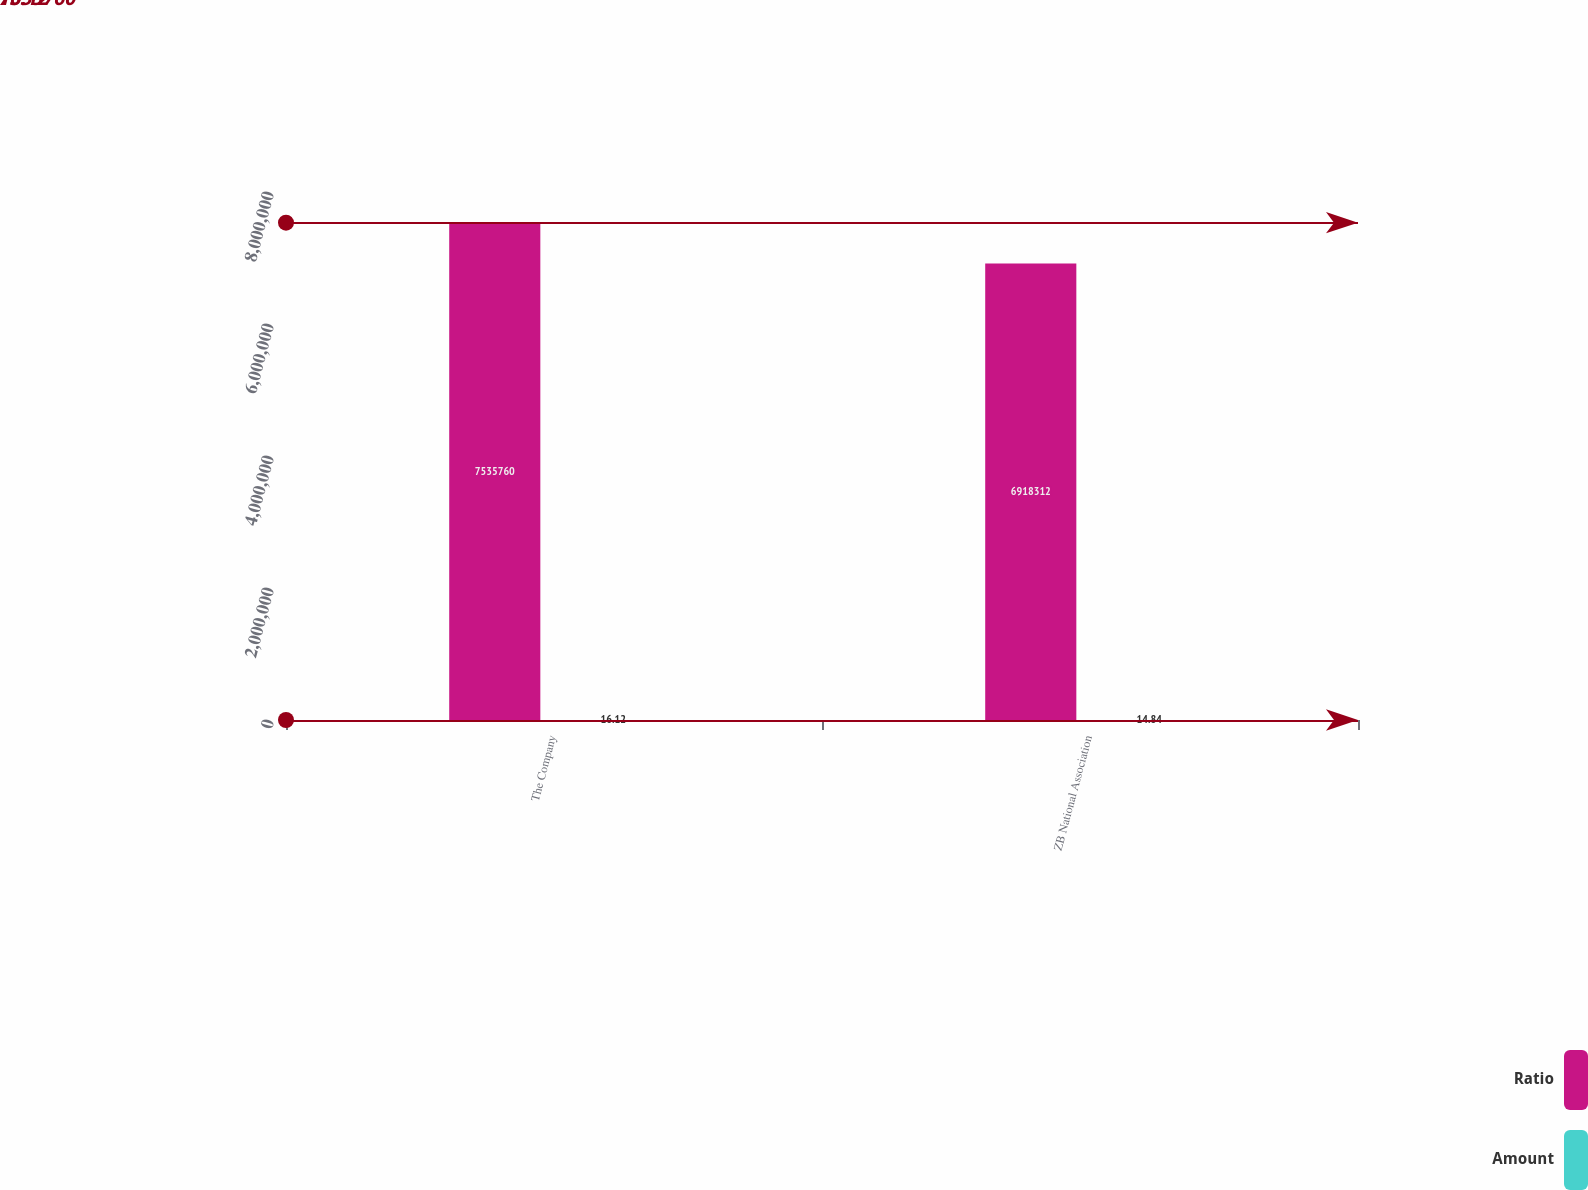<chart> <loc_0><loc_0><loc_500><loc_500><stacked_bar_chart><ecel><fcel>The Company<fcel>ZB National Association<nl><fcel>Ratio<fcel>7.53576e+06<fcel>6.91831e+06<nl><fcel>Amount<fcel>16.12<fcel>14.84<nl></chart> 